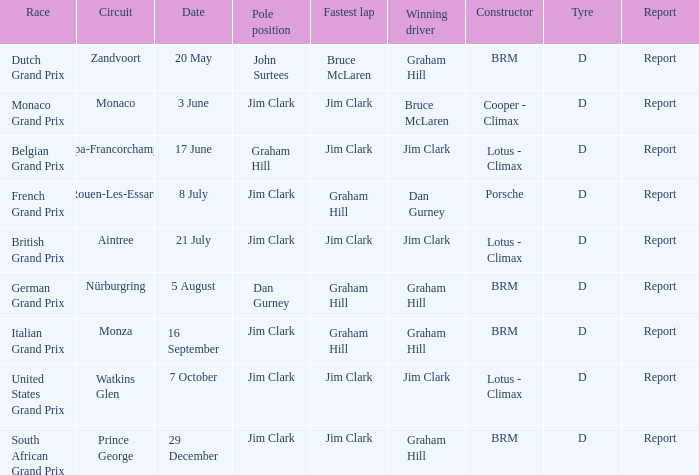When is the monaco circuit scheduled? 3 June. 